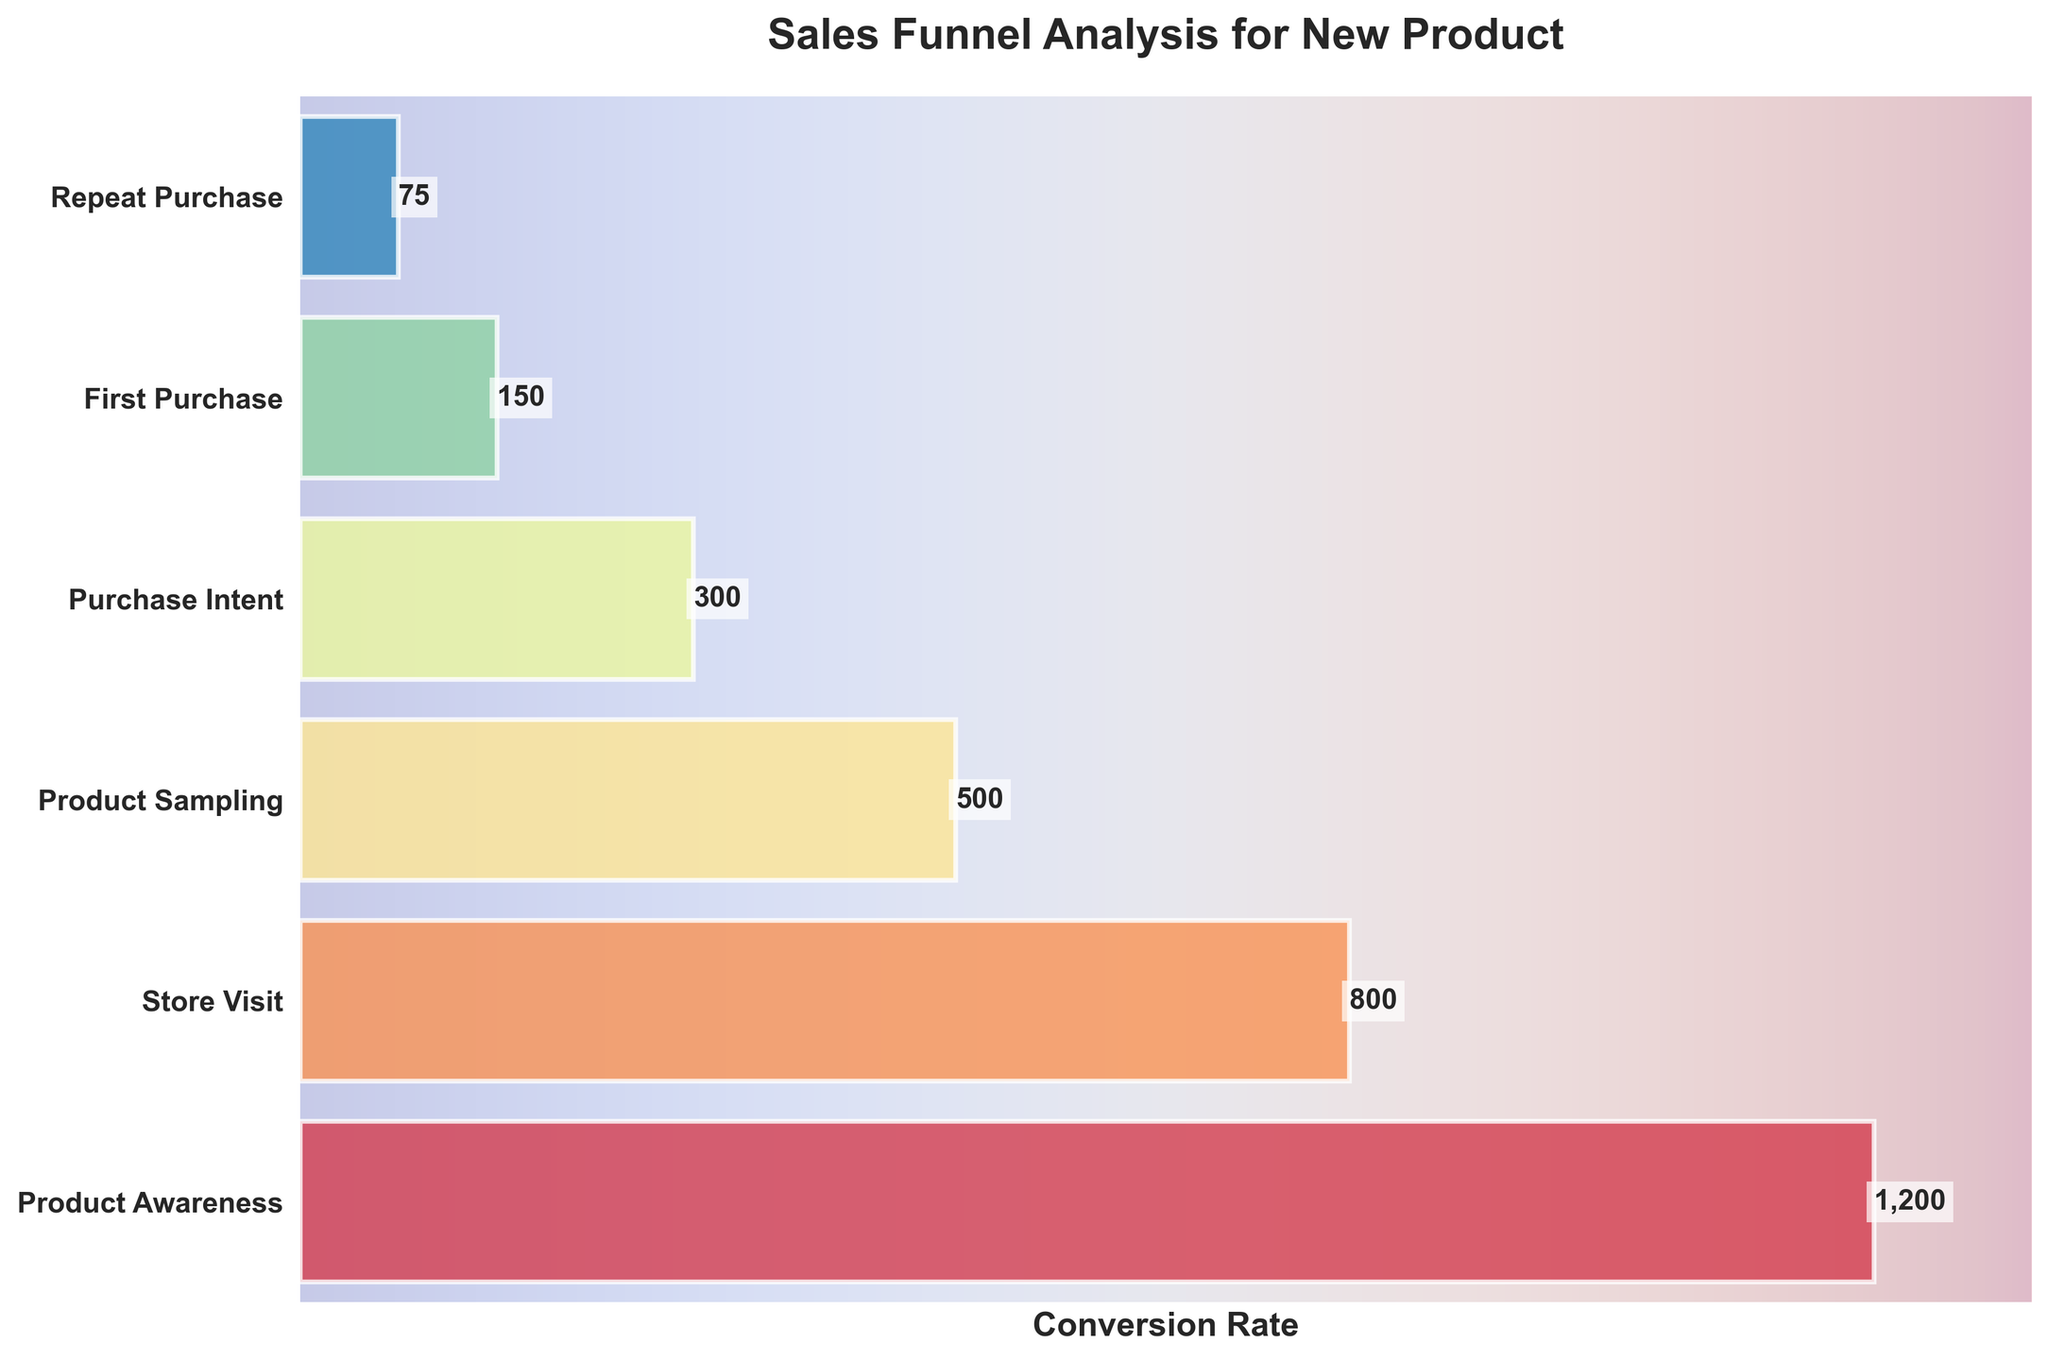what is the title of the chart? The title of the chart is displayed at the top of the figure and it reads "Sales Funnel Analysis for New Product".
Answer: Sales Funnel Analysis for New Product How many stages are there in the sales funnel? The funnel chart displays each stage as a horizontal bar. Counting these bars indicates there are six stages in the sales funnel.
Answer: 6 Which stage has the highest number of customers? The first stage, "Product Awareness," has the widest bar, indicating the highest number of customers. The label on the bar confirms it shows 1200 customers.
Answer: Product Awareness What is the difference in the number of customers between Product Awareness and Repeat Purchase? The number of customers in "Product Awareness" is 1200, and in "Repeat Purchase" it is 75. Subtract the number of Repeat Purchase customers from Product Awareness customers: 1200 - 75.
Answer: 1125 What percentage of customers who visit the store go on to sample the product? To find the percentage, divide the number of customers who sampled the product (500) by the number of customers who visited the store (800) and multiply by 100: (500/800) * 100.
Answer: 62.5% Which stage has exactly half the number of customers as the previous stage? The "First Purchase" stage has 150 customers, which is exactly half of the 300 customers in the "Purchase Intent" stage.
Answer: First Purchase How many customers are lost between the Store Visit and Product Sampling stages? Subtract the number of customers in the Product Sampling stage (500) from the Store Visit stage (800): 800 - 500.
Answer: 300 What is the conversion rate from the first purchase to a repeat purchase? The number of customers making a first purchase is 150 and those making a repeat purchase is 75. Divide 75 by 150 and multiply by 100 to get the conversion rate: (75/150) * 100.
Answer: 50% Which stage shows the largest drop in the number of customers? Comparing customer drop numbers between consecutive stages, the largest decrease is from "Product Awareness" (1200) to "Store Visit" (800), which is a drop of 400 customers.
Answer: Product Awareness to Store Visit 